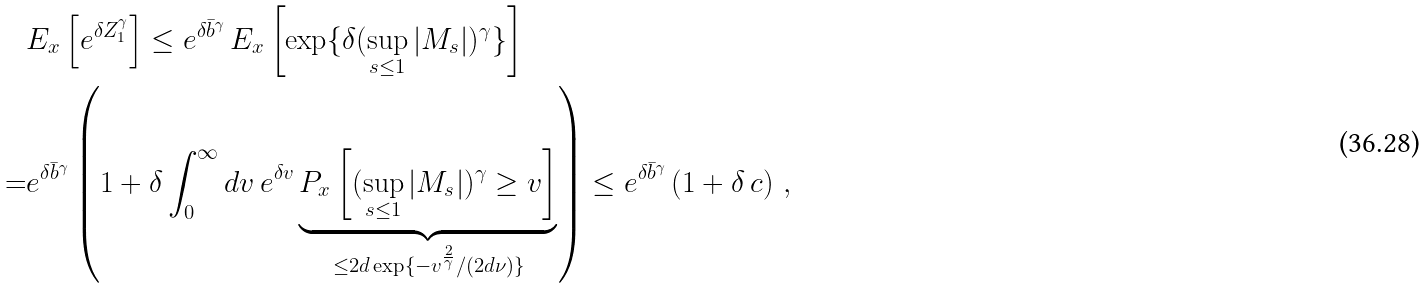Convert formula to latex. <formula><loc_0><loc_0><loc_500><loc_500>& E _ { x } \left [ e ^ { \delta Z _ { 1 } ^ { \gamma } } \right ] \leq e ^ { \delta \bar { b } ^ { \gamma } } \, E _ { x } \left [ \exp \{ \delta ( \sup _ { s \leq 1 } | M _ { s } | ) ^ { \gamma } \} \right ] \\ = & e ^ { \delta \bar { b } ^ { \gamma } } \left ( 1 + \delta \int ^ { \infty } _ { 0 } d v \, e ^ { \delta v } \underbrace { P _ { x } \left [ ( \sup _ { s \leq 1 } | M _ { s } | ) ^ { \gamma } \geq v \right ] } _ { \leq 2 d \exp \{ - v ^ { \frac { 2 } { \gamma } } / ( 2 d \nu ) \} } \right ) \leq e ^ { \delta \bar { b } ^ { \gamma } } \left ( 1 + \delta \, c \right ) \, ,</formula> 